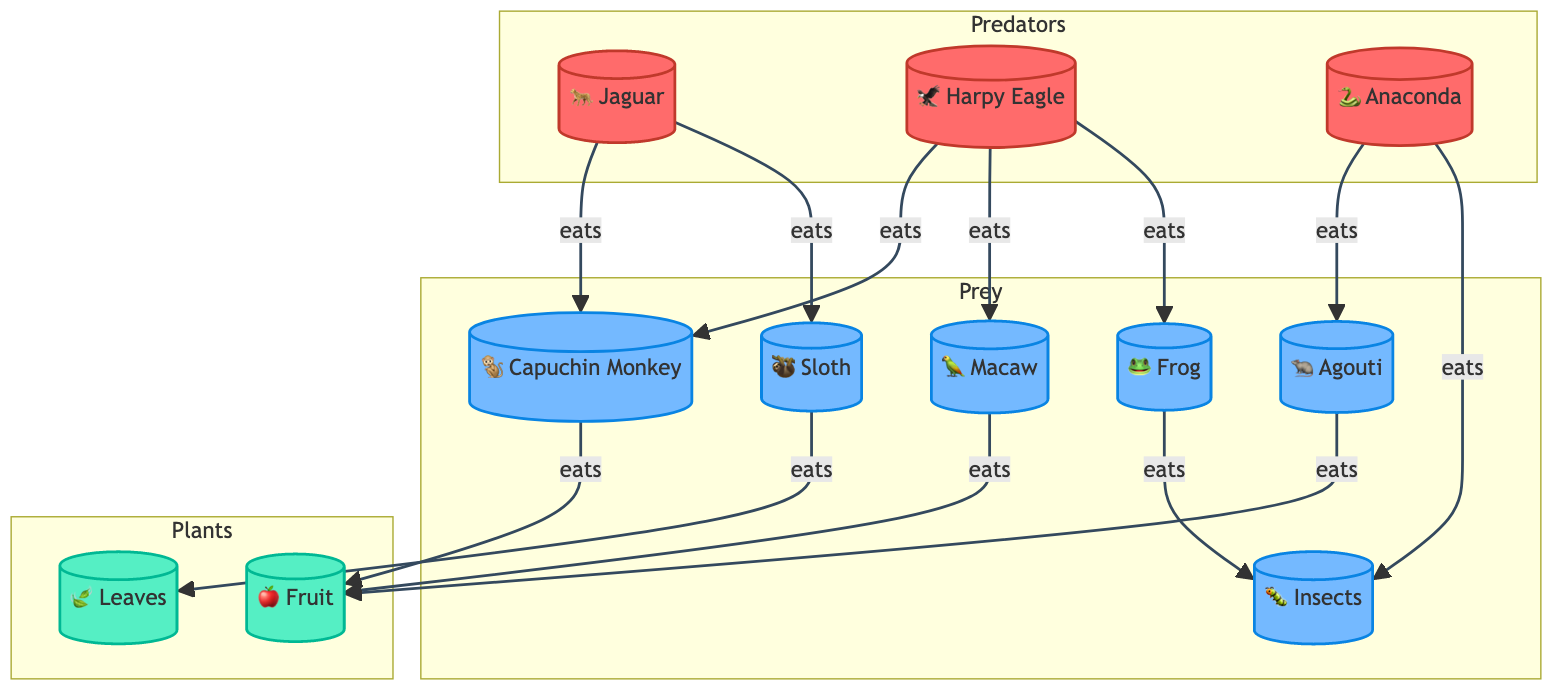What are the three predatory animals in this food web? The diagram lists three predators under the "Predators" subgraph: Jaguar, Harpy Eagle, and Anaconda.
Answer: Jaguar, Harpy Eagle, Anaconda How many prey animals are present in the food web? There are six prey animals labeled under the "Prey" subgraph: Capuchin Monkey, Sloth, Agouti, Macaw, Frog, and Insects. Counting these yields a total of six.
Answer: 6 Which prey animal is eaten by both the Jaguar and the Harpy Eagle? The Capuchin Monkey is the only prey animal that shows connections from both the Jaguar and the Harpy Eagle indicating that both predators eat it.
Answer: Capuchin Monkey What do Agoutis eat in this food web? Looking at the relationship in the diagram, Agouti is connected to Fruit, which indicates that they eat fruit.
Answer: Fruit Which predator consumes the Agouti? The diagram indicates that the Anaconda has an edge that points toward the Agouti, showing it is the predator that eats Agouti.
Answer: Anaconda What type of plant do Sloths eat? The diagram connects the Sloth to Leaves, which indicates that leaves are their food source.
Answer: Leaves How many edges originate from the Harpy Eagle? The Harpy Eagle has three edges pointing towards three different prey (Monkey, Macaw, Frog), thus originating three edges.
Answer: 3 Which insect is eaten by the Anaconda? The diagram shows a direct connection from the Anaconda to Insects, which indicates that Insects are consumed by the Anaconda.
Answer: Insects What is the primary diet of the Jaguar? Analyzing the connections from the Jaguar, it eats both the Capuchin Monkey and the Sloth, which indicates its primary diet consists of these two animals.
Answer: Capuchin Monkey, Sloth 